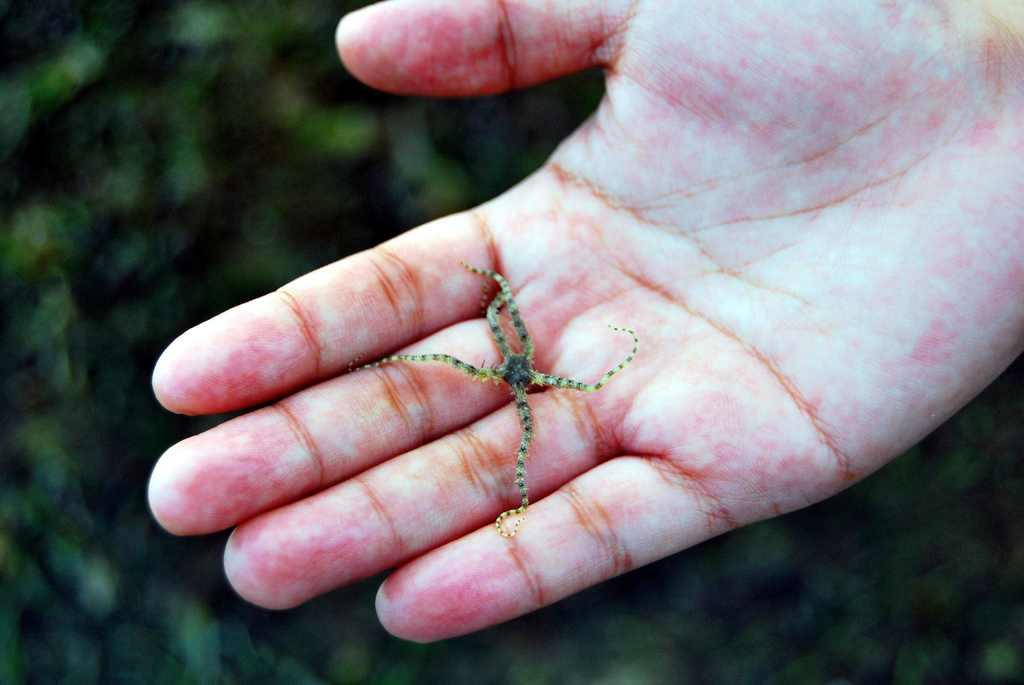What is the main subject of the image? The main subject of the image is an insect on a hand. Can you describe the background of the image? The background of the image is blurred. What type of basin is visible in the image? There is no basin present in the image. What role does the doctor play in the image? There is no doctor present in the image. 